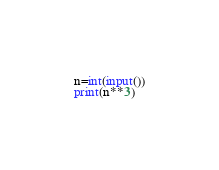<code> <loc_0><loc_0><loc_500><loc_500><_Python_>n=int(input())
print(n**3)</code> 